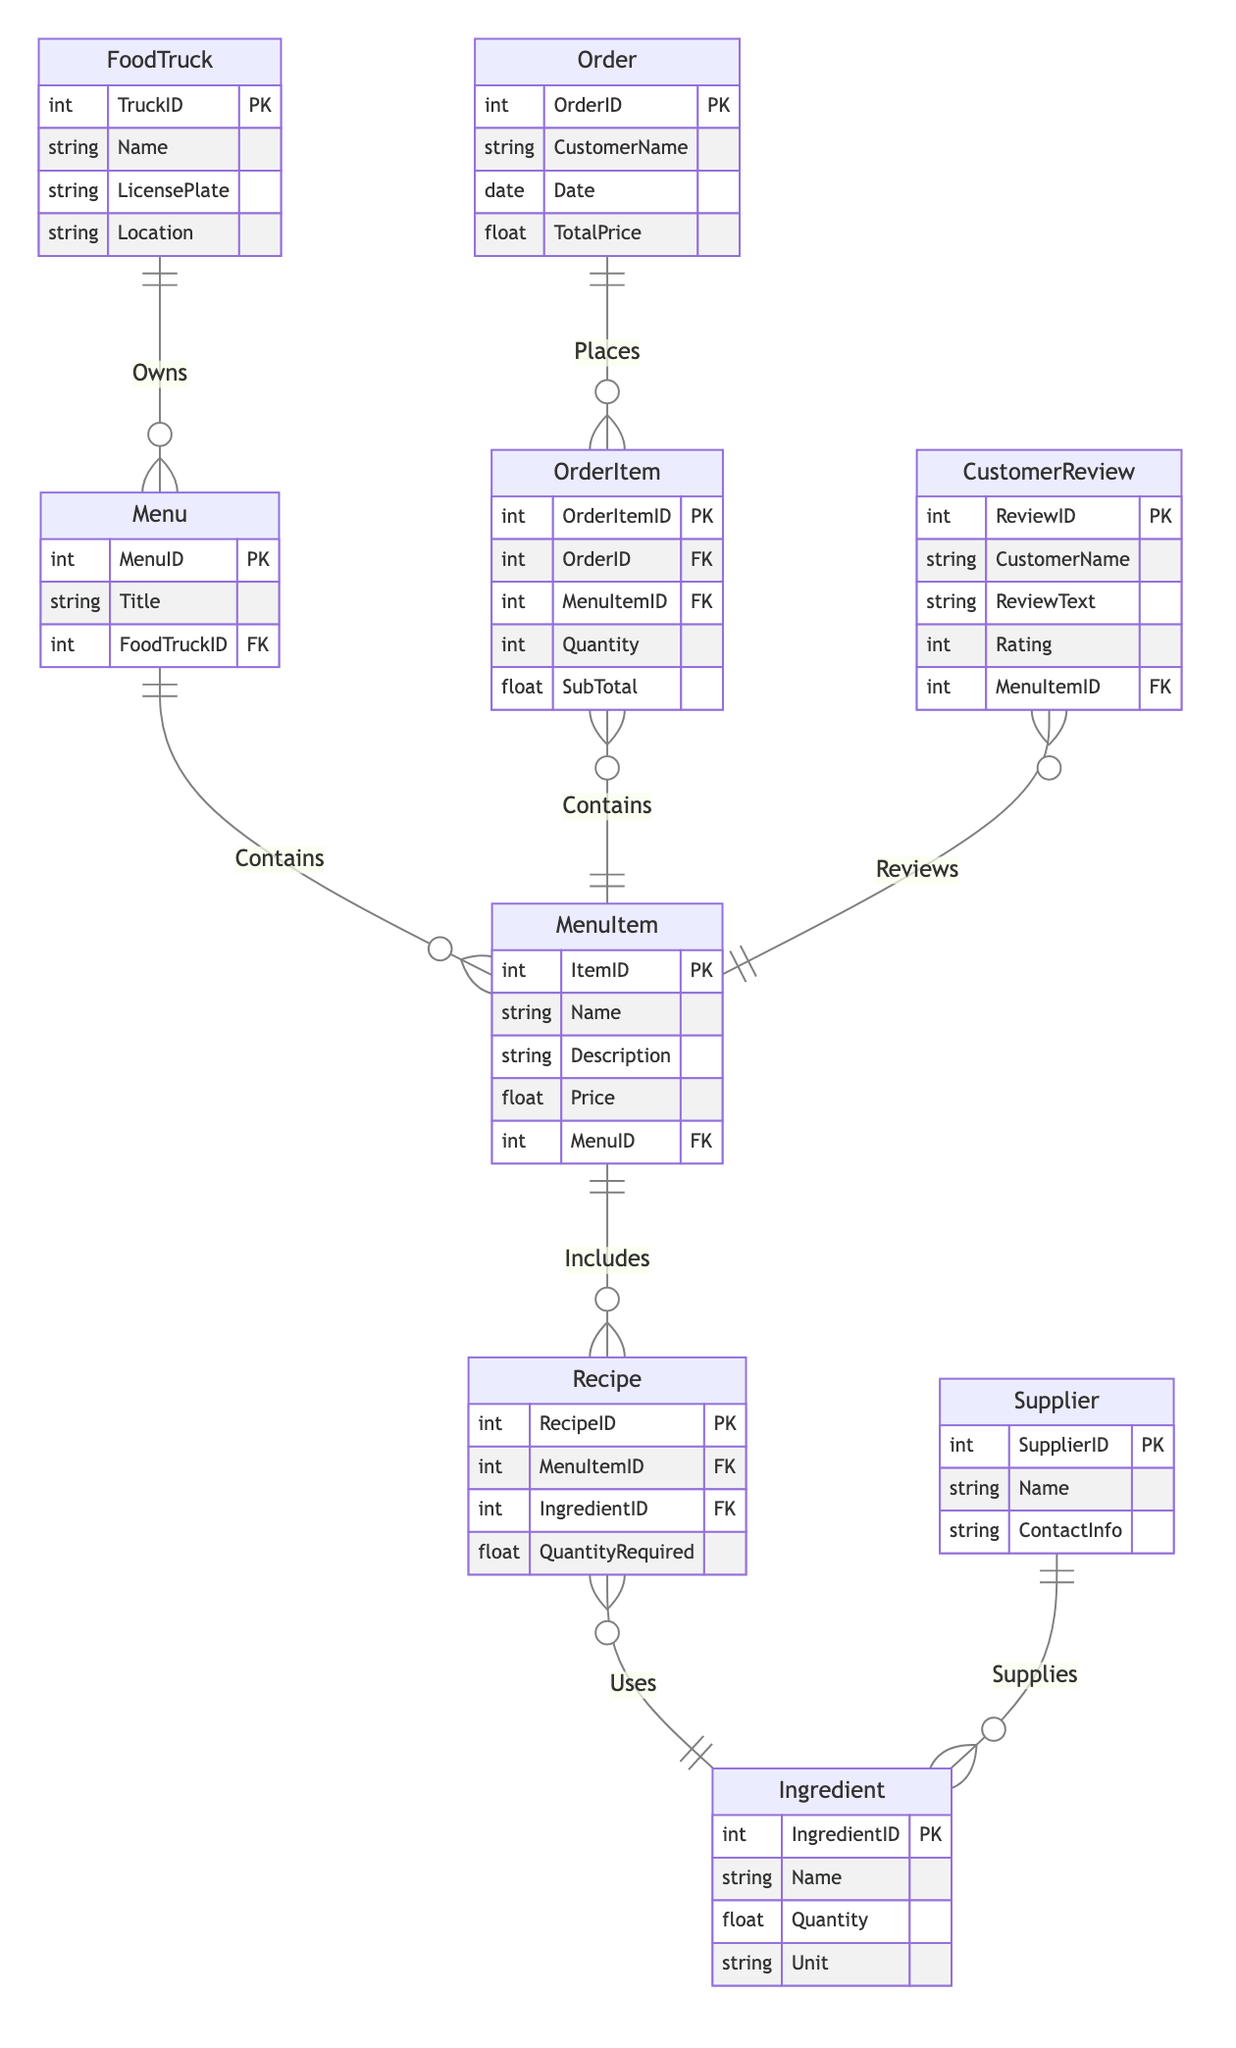What is the primary key of the MenuItem entity? The primary key of the MenuItem entity is specified in the diagram as ItemID, which uniquely identifies each menu item.
Answer: ItemID How many entities are in the diagram? By counting the listed entities, we see there are 9 entities: Food Truck, Menu, MenuItem, Ingredient, Recipe, Supplier, Order, OrderItem, and CustomerReview.
Answer: 9 Which entity has a one-to-many relationship with the Menu entity? Referring to the relationship "Owns," the Food Truck entity is indicated to have a one-to-many relationship with the Menu entity, meaning one food truck can own many menus.
Answer: Food Truck What is the relationship type between Supplier and Ingredient? The relationship type between Supplier and Ingredient is "one-to-many," indicating a single supplier can supply multiple ingredients.
Answer: one-to-many How many ingredients can a recipe use? The relationship "Uses" indicates that a recipe can use many ingredients, meaning there can be multiple ingredients linked to a single recipe.
Answer: many What does the OrderItem entity contain? The OrderItem entity contains MenuItem, which shows that each order item is specifically associated with a menu item as indicated by the relationship "Contains."
Answer: MenuItem Who can write a CustomerReview? The CustomerReview entity shows that reviews are written by customers, as each review must include a CustomerName according to its attributes.
Answer: Customer Describe the relationship between OrderItem and MenuItem. The relationship "Contains" between OrderItem and MenuItem is "many-to-one," indicating that multiple order items can refer to a single menu item.
Answer: many-to-one What is the key attribute of the Recipe entity? The key attribute of the Recipe entity is RecipeID, which uniquely identifies each recipe in the diagram.
Answer: RecipeID 